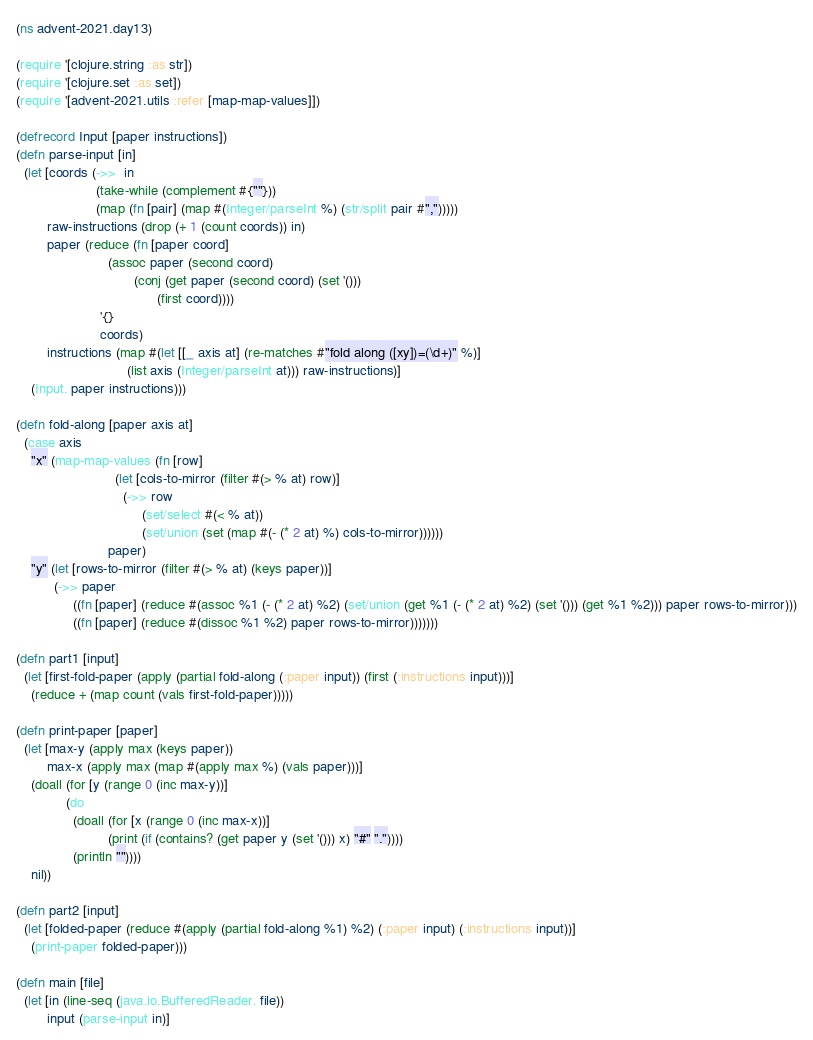<code> <loc_0><loc_0><loc_500><loc_500><_Clojure_>(ns advent-2021.day13)

(require '[clojure.string :as str])
(require '[clojure.set :as set])
(require '[advent-2021.utils :refer [map-map-values]])

(defrecord Input [paper instructions])
(defn parse-input [in]
  (let [coords (->>  in
                     (take-while (complement #{""}))
                     (map (fn [pair] (map #(Integer/parseInt %) (str/split pair #",")))))
        raw-instructions (drop (+ 1 (count coords)) in)
        paper (reduce (fn [paper coord]
                        (assoc paper (second coord)
                               (conj (get paper (second coord) (set '()))
                                     (first coord))))
                      '{}
                      coords)
        instructions (map #(let [[_ axis at] (re-matches #"fold along ([xy])=(\d+)" %)]
                             (list axis (Integer/parseInt at))) raw-instructions)]
    (Input. paper instructions)))

(defn fold-along [paper axis at]
  (case axis
    "x" (map-map-values (fn [row]
                          (let [cols-to-mirror (filter #(> % at) row)]
                            (->> row
                                 (set/select #(< % at))
                                 (set/union (set (map #(- (* 2 at) %) cols-to-mirror))))))
                        paper)
    "y" (let [rows-to-mirror (filter #(> % at) (keys paper))]
          (->> paper
               ((fn [paper] (reduce #(assoc %1 (- (* 2 at) %2) (set/union (get %1 (- (* 2 at) %2) (set '())) (get %1 %2))) paper rows-to-mirror)))
               ((fn [paper] (reduce #(dissoc %1 %2) paper rows-to-mirror)))))))

(defn part1 [input]
  (let [first-fold-paper (apply (partial fold-along (:paper input)) (first (:instructions input)))]
    (reduce + (map count (vals first-fold-paper)))))

(defn print-paper [paper]
  (let [max-y (apply max (keys paper))
        max-x (apply max (map #(apply max %) (vals paper)))]
    (doall (for [y (range 0 (inc max-y))]
             (do
               (doall (for [x (range 0 (inc max-x))]
                        (print (if (contains? (get paper y (set '())) x) "#" "."))))
               (println ""))))
    nil))

(defn part2 [input]
  (let [folded-paper (reduce #(apply (partial fold-along %1) %2) (:paper input) (:instructions input))]
    (print-paper folded-paper)))

(defn main [file]
  (let [in (line-seq (java.io.BufferedReader. file))
        input (parse-input in)]</code> 